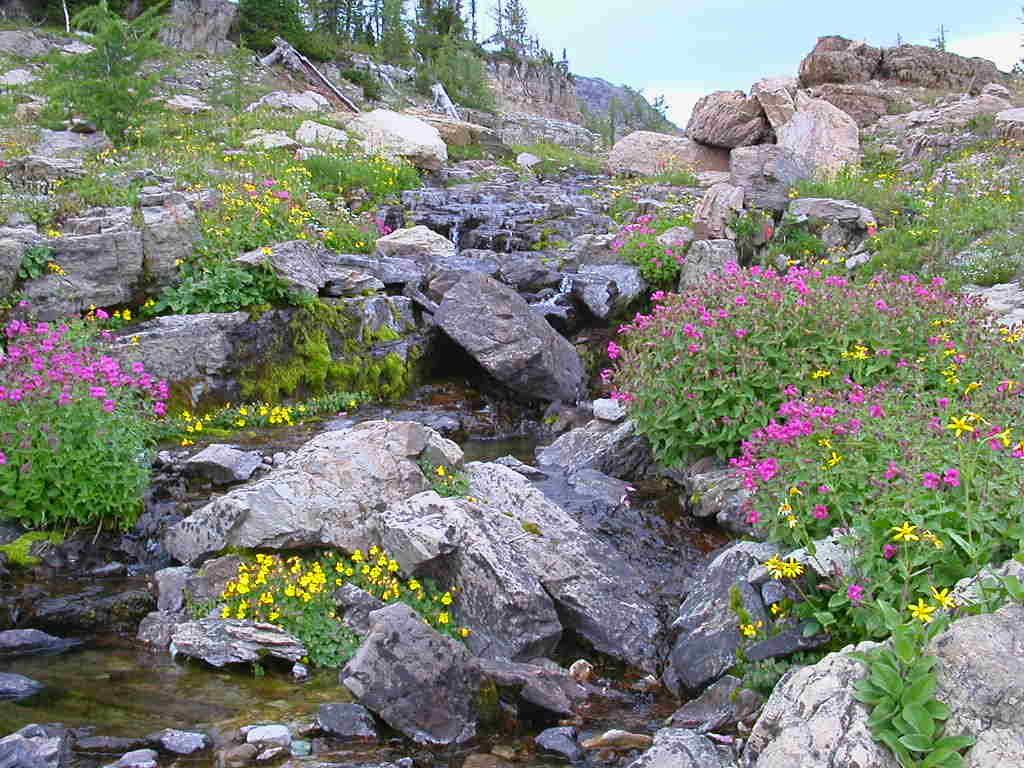What types of living organisms can be seen in the image? Plants and flowers are visible in the image. What other elements can be seen in the image besides plants and flowers? Rocks and water are present in the image. What is visible in the background of the image? The background of the image includes rocks. What is visible at the top of the image? The sky is visible at the top of the image. What type of loaf is being baked in the image? There is no loaf present in the image; it features plants, flowers, rocks, water, and the sky. 